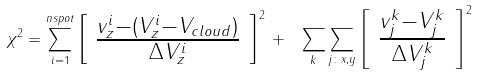Convert formula to latex. <formula><loc_0><loc_0><loc_500><loc_500>\chi ^ { 2 } = \sum _ { i = 1 } ^ { n s p o t } \left [ \begin{array} { c } \frac { v ^ { i } _ { z } - ( V ^ { i } _ { z } - V _ { c l o u d } ) } { \Delta V ^ { i } _ { z } } \end{array} \right ] ^ { 2 } \, + \, \ \sum _ { k } \sum _ { j \colon x , y } \left [ \begin{array} { c } \frac { v ^ { k } _ { j } - V ^ { k } _ { j } } { \Delta V ^ { k } _ { j } } \end{array} \right ] ^ { 2 }</formula> 